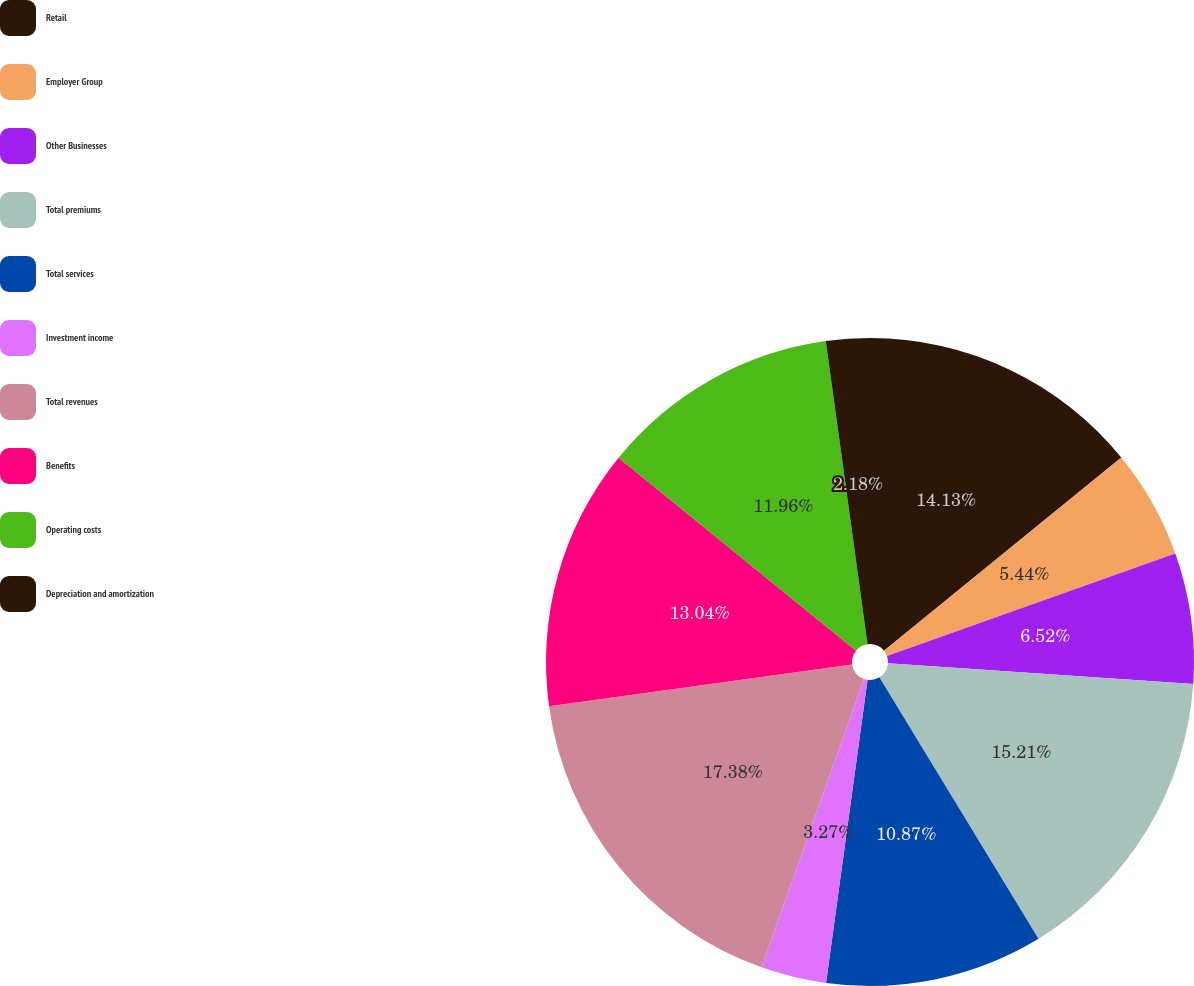Convert chart. <chart><loc_0><loc_0><loc_500><loc_500><pie_chart><fcel>Retail<fcel>Employer Group<fcel>Other Businesses<fcel>Total premiums<fcel>Total services<fcel>Investment income<fcel>Total revenues<fcel>Benefits<fcel>Operating costs<fcel>Depreciation and amortization<nl><fcel>14.13%<fcel>5.44%<fcel>6.52%<fcel>15.21%<fcel>10.87%<fcel>3.27%<fcel>17.39%<fcel>13.04%<fcel>11.96%<fcel>2.18%<nl></chart> 